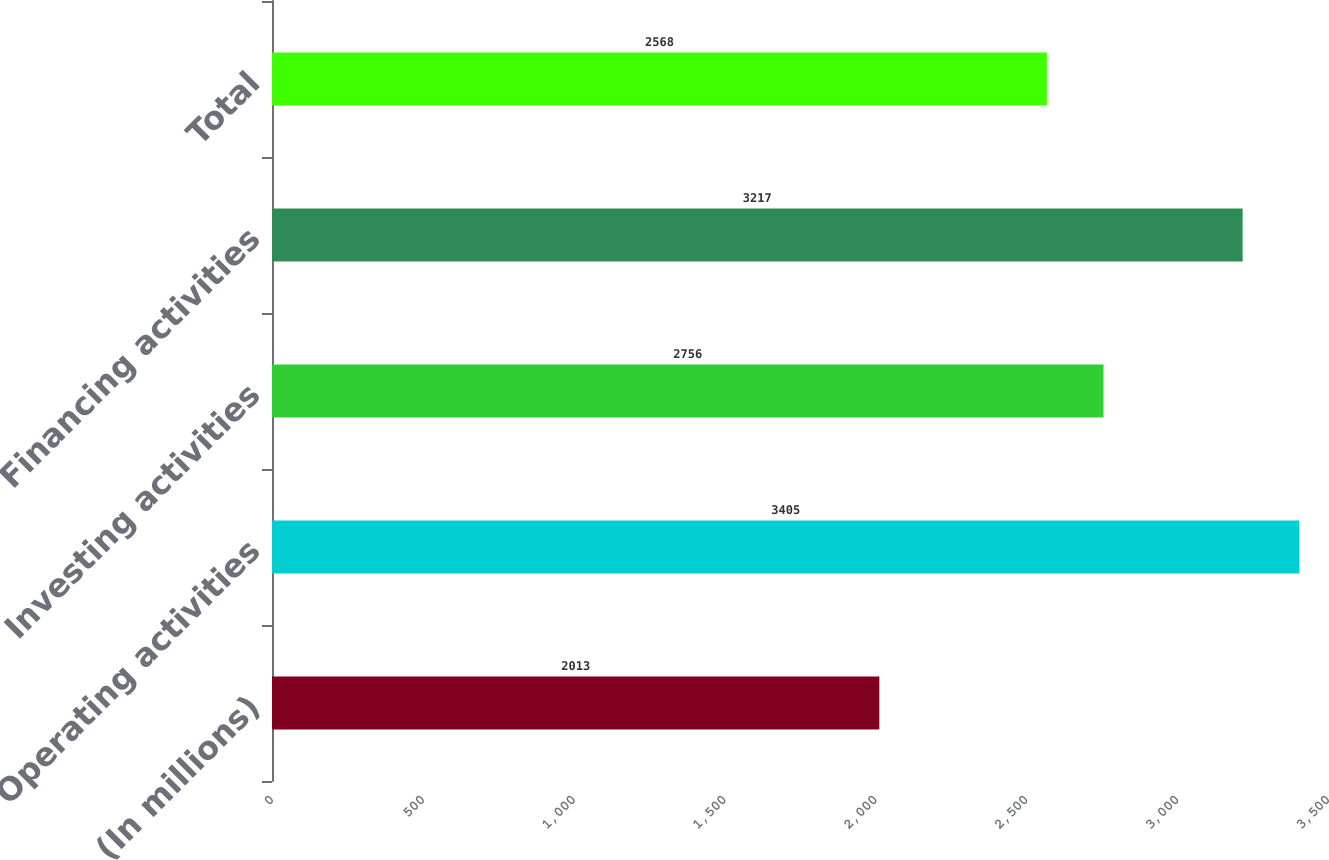Convert chart. <chart><loc_0><loc_0><loc_500><loc_500><bar_chart><fcel>(In millions)<fcel>Operating activities<fcel>Investing activities<fcel>Financing activities<fcel>Total<nl><fcel>2013<fcel>3405<fcel>2756<fcel>3217<fcel>2568<nl></chart> 